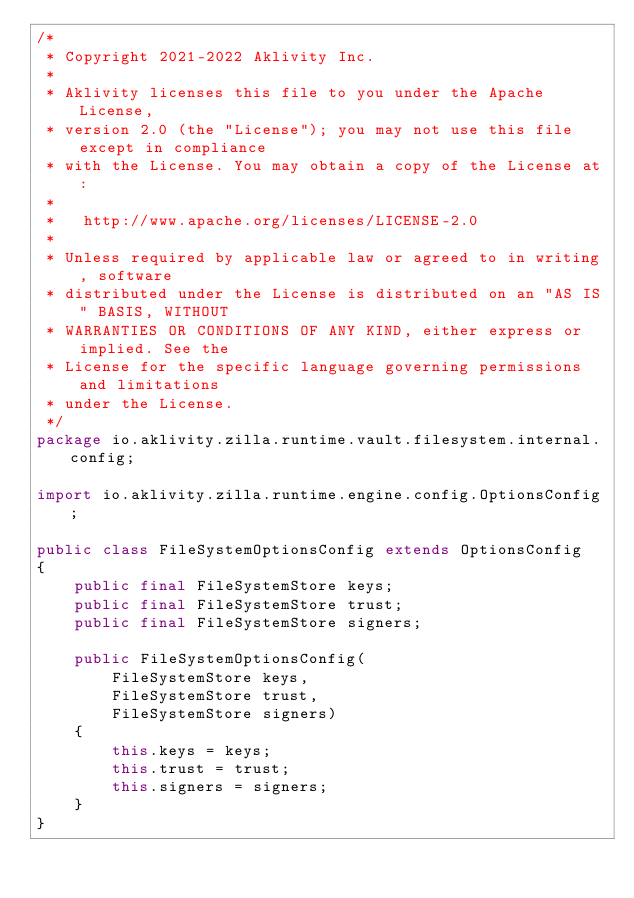<code> <loc_0><loc_0><loc_500><loc_500><_Java_>/*
 * Copyright 2021-2022 Aklivity Inc.
 *
 * Aklivity licenses this file to you under the Apache License,
 * version 2.0 (the "License"); you may not use this file except in compliance
 * with the License. You may obtain a copy of the License at:
 *
 *   http://www.apache.org/licenses/LICENSE-2.0
 *
 * Unless required by applicable law or agreed to in writing, software
 * distributed under the License is distributed on an "AS IS" BASIS, WITHOUT
 * WARRANTIES OR CONDITIONS OF ANY KIND, either express or implied. See the
 * License for the specific language governing permissions and limitations
 * under the License.
 */
package io.aklivity.zilla.runtime.vault.filesystem.internal.config;

import io.aklivity.zilla.runtime.engine.config.OptionsConfig;

public class FileSystemOptionsConfig extends OptionsConfig
{
    public final FileSystemStore keys;
    public final FileSystemStore trust;
    public final FileSystemStore signers;

    public FileSystemOptionsConfig(
        FileSystemStore keys,
        FileSystemStore trust,
        FileSystemStore signers)
    {
        this.keys = keys;
        this.trust = trust;
        this.signers = signers;
    }
}
</code> 